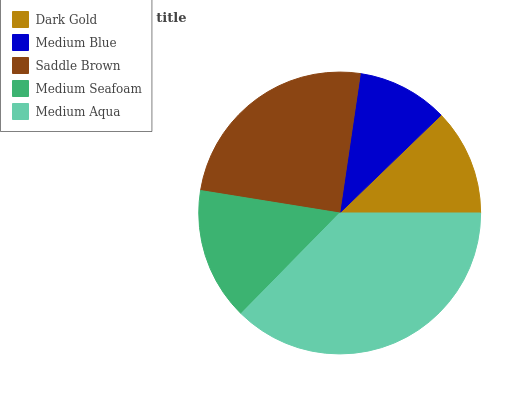Is Medium Blue the minimum?
Answer yes or no. Yes. Is Medium Aqua the maximum?
Answer yes or no. Yes. Is Saddle Brown the minimum?
Answer yes or no. No. Is Saddle Brown the maximum?
Answer yes or no. No. Is Saddle Brown greater than Medium Blue?
Answer yes or no. Yes. Is Medium Blue less than Saddle Brown?
Answer yes or no. Yes. Is Medium Blue greater than Saddle Brown?
Answer yes or no. No. Is Saddle Brown less than Medium Blue?
Answer yes or no. No. Is Medium Seafoam the high median?
Answer yes or no. Yes. Is Medium Seafoam the low median?
Answer yes or no. Yes. Is Medium Aqua the high median?
Answer yes or no. No. Is Saddle Brown the low median?
Answer yes or no. No. 